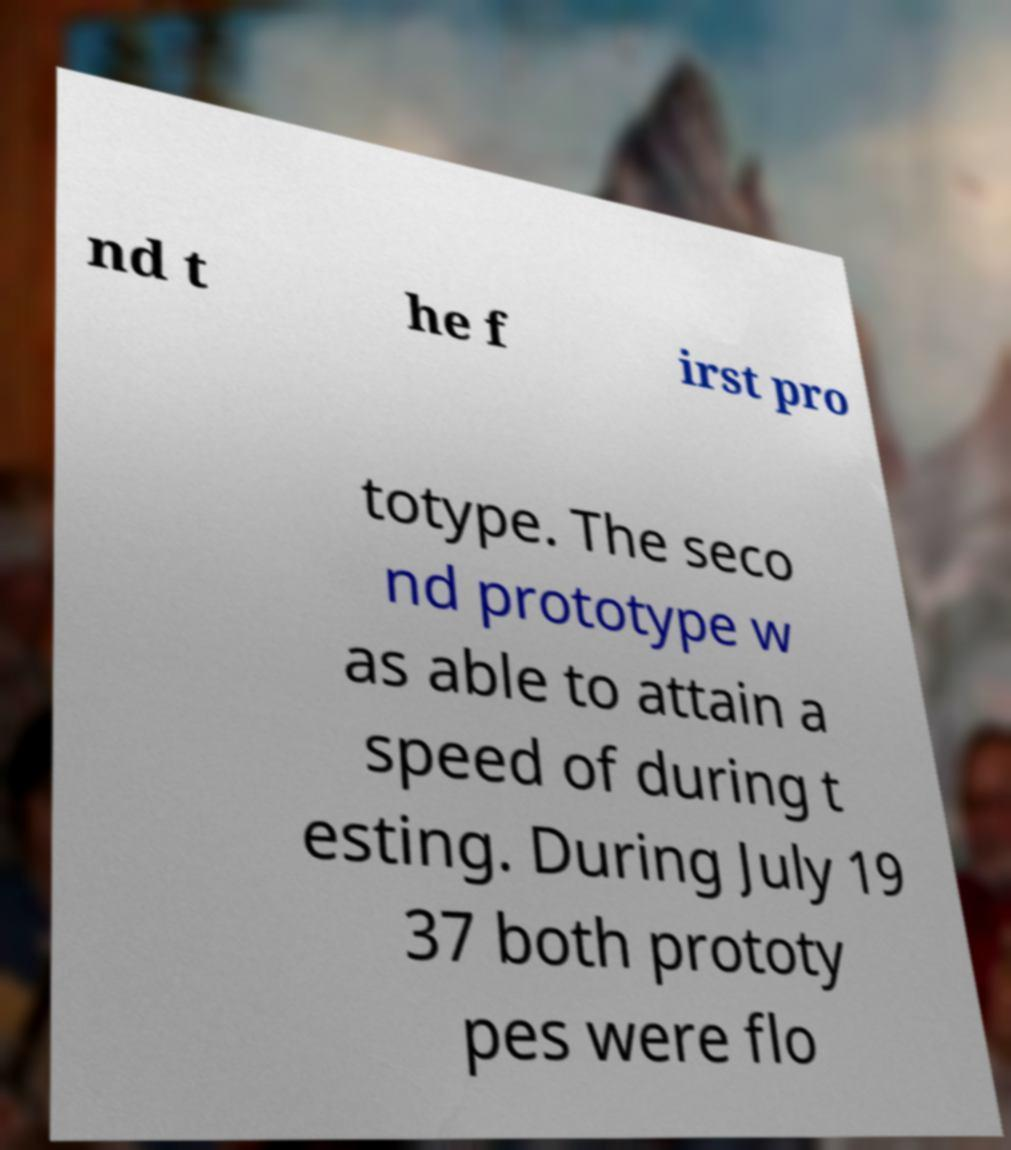There's text embedded in this image that I need extracted. Can you transcribe it verbatim? nd t he f irst pro totype. The seco nd prototype w as able to attain a speed of during t esting. During July 19 37 both prototy pes were flo 